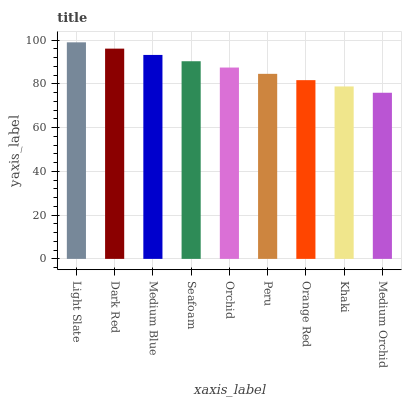Is Medium Orchid the minimum?
Answer yes or no. Yes. Is Light Slate the maximum?
Answer yes or no. Yes. Is Dark Red the minimum?
Answer yes or no. No. Is Dark Red the maximum?
Answer yes or no. No. Is Light Slate greater than Dark Red?
Answer yes or no. Yes. Is Dark Red less than Light Slate?
Answer yes or no. Yes. Is Dark Red greater than Light Slate?
Answer yes or no. No. Is Light Slate less than Dark Red?
Answer yes or no. No. Is Orchid the high median?
Answer yes or no. Yes. Is Orchid the low median?
Answer yes or no. Yes. Is Peru the high median?
Answer yes or no. No. Is Orange Red the low median?
Answer yes or no. No. 